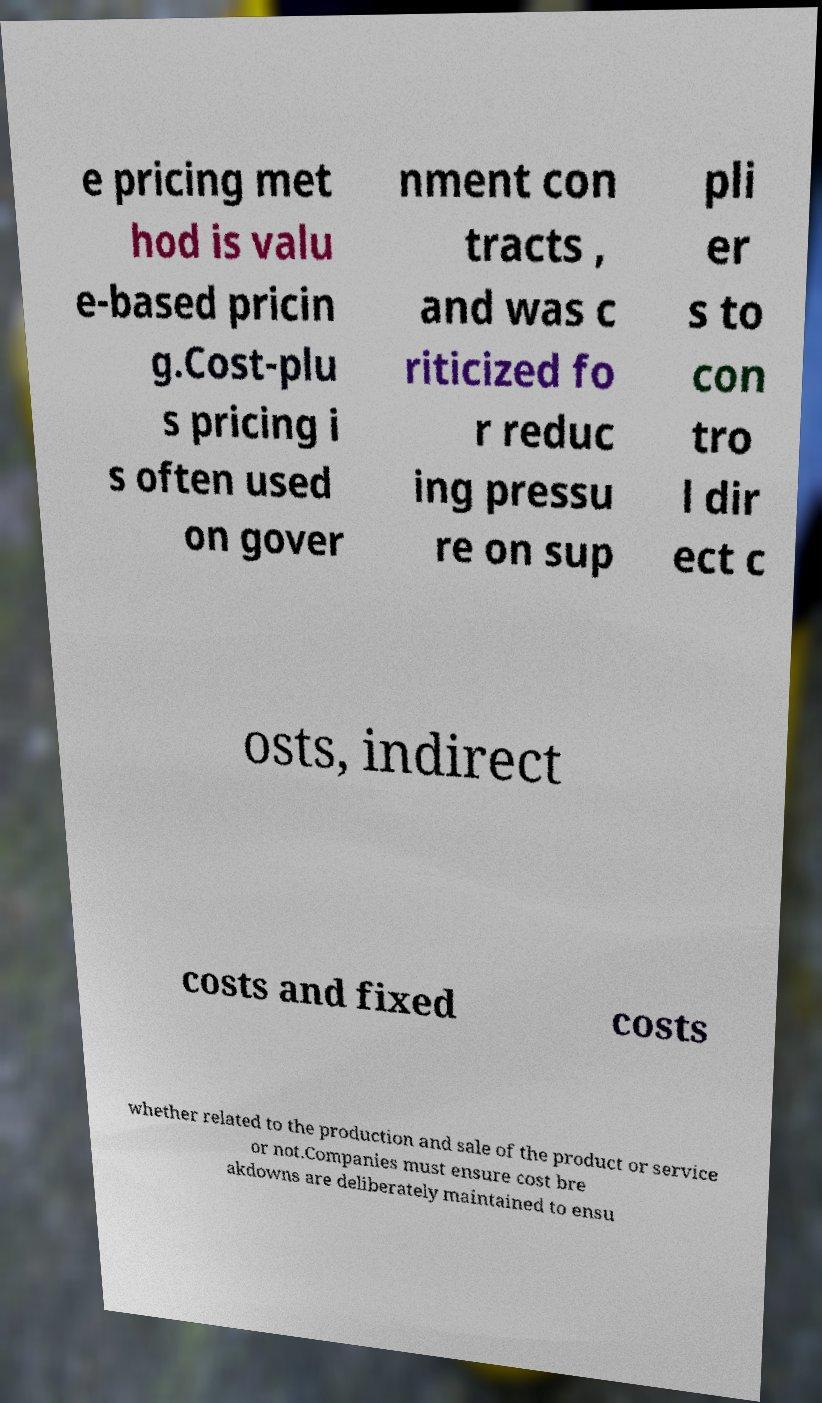Can you read and provide the text displayed in the image?This photo seems to have some interesting text. Can you extract and type it out for me? e pricing met hod is valu e-based pricin g.Cost-plu s pricing i s often used on gover nment con tracts , and was c riticized fo r reduc ing pressu re on sup pli er s to con tro l dir ect c osts, indirect costs and fixed costs whether related to the production and sale of the product or service or not.Companies must ensure cost bre akdowns are deliberately maintained to ensu 